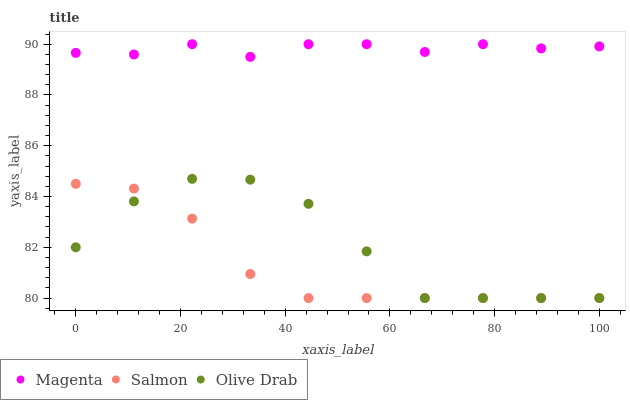Does Salmon have the minimum area under the curve?
Answer yes or no. Yes. Does Magenta have the maximum area under the curve?
Answer yes or no. Yes. Does Olive Drab have the minimum area under the curve?
Answer yes or no. No. Does Olive Drab have the maximum area under the curve?
Answer yes or no. No. Is Salmon the smoothest?
Answer yes or no. Yes. Is Olive Drab the roughest?
Answer yes or no. Yes. Is Olive Drab the smoothest?
Answer yes or no. No. Is Salmon the roughest?
Answer yes or no. No. Does Salmon have the lowest value?
Answer yes or no. Yes. Does Magenta have the highest value?
Answer yes or no. Yes. Does Olive Drab have the highest value?
Answer yes or no. No. Is Salmon less than Magenta?
Answer yes or no. Yes. Is Magenta greater than Olive Drab?
Answer yes or no. Yes. Does Olive Drab intersect Salmon?
Answer yes or no. Yes. Is Olive Drab less than Salmon?
Answer yes or no. No. Is Olive Drab greater than Salmon?
Answer yes or no. No. Does Salmon intersect Magenta?
Answer yes or no. No. 